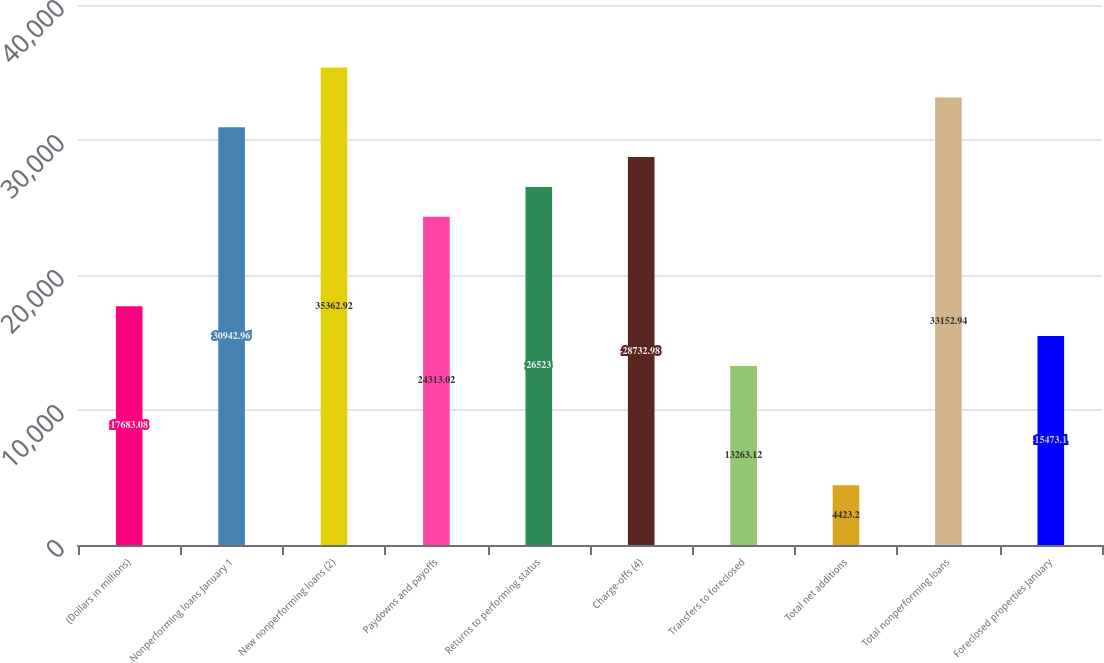Convert chart. <chart><loc_0><loc_0><loc_500><loc_500><bar_chart><fcel>(Dollars in millions)<fcel>Nonperforming loans January 1<fcel>New nonperforming loans (2)<fcel>Paydowns and payoffs<fcel>Returns to performing status<fcel>Charge-offs (4)<fcel>Transfers to foreclosed<fcel>Total net additions<fcel>Total nonperforming loans<fcel>Foreclosed properties January<nl><fcel>17683.1<fcel>30943<fcel>35362.9<fcel>24313<fcel>26523<fcel>28733<fcel>13263.1<fcel>4423.2<fcel>33152.9<fcel>15473.1<nl></chart> 